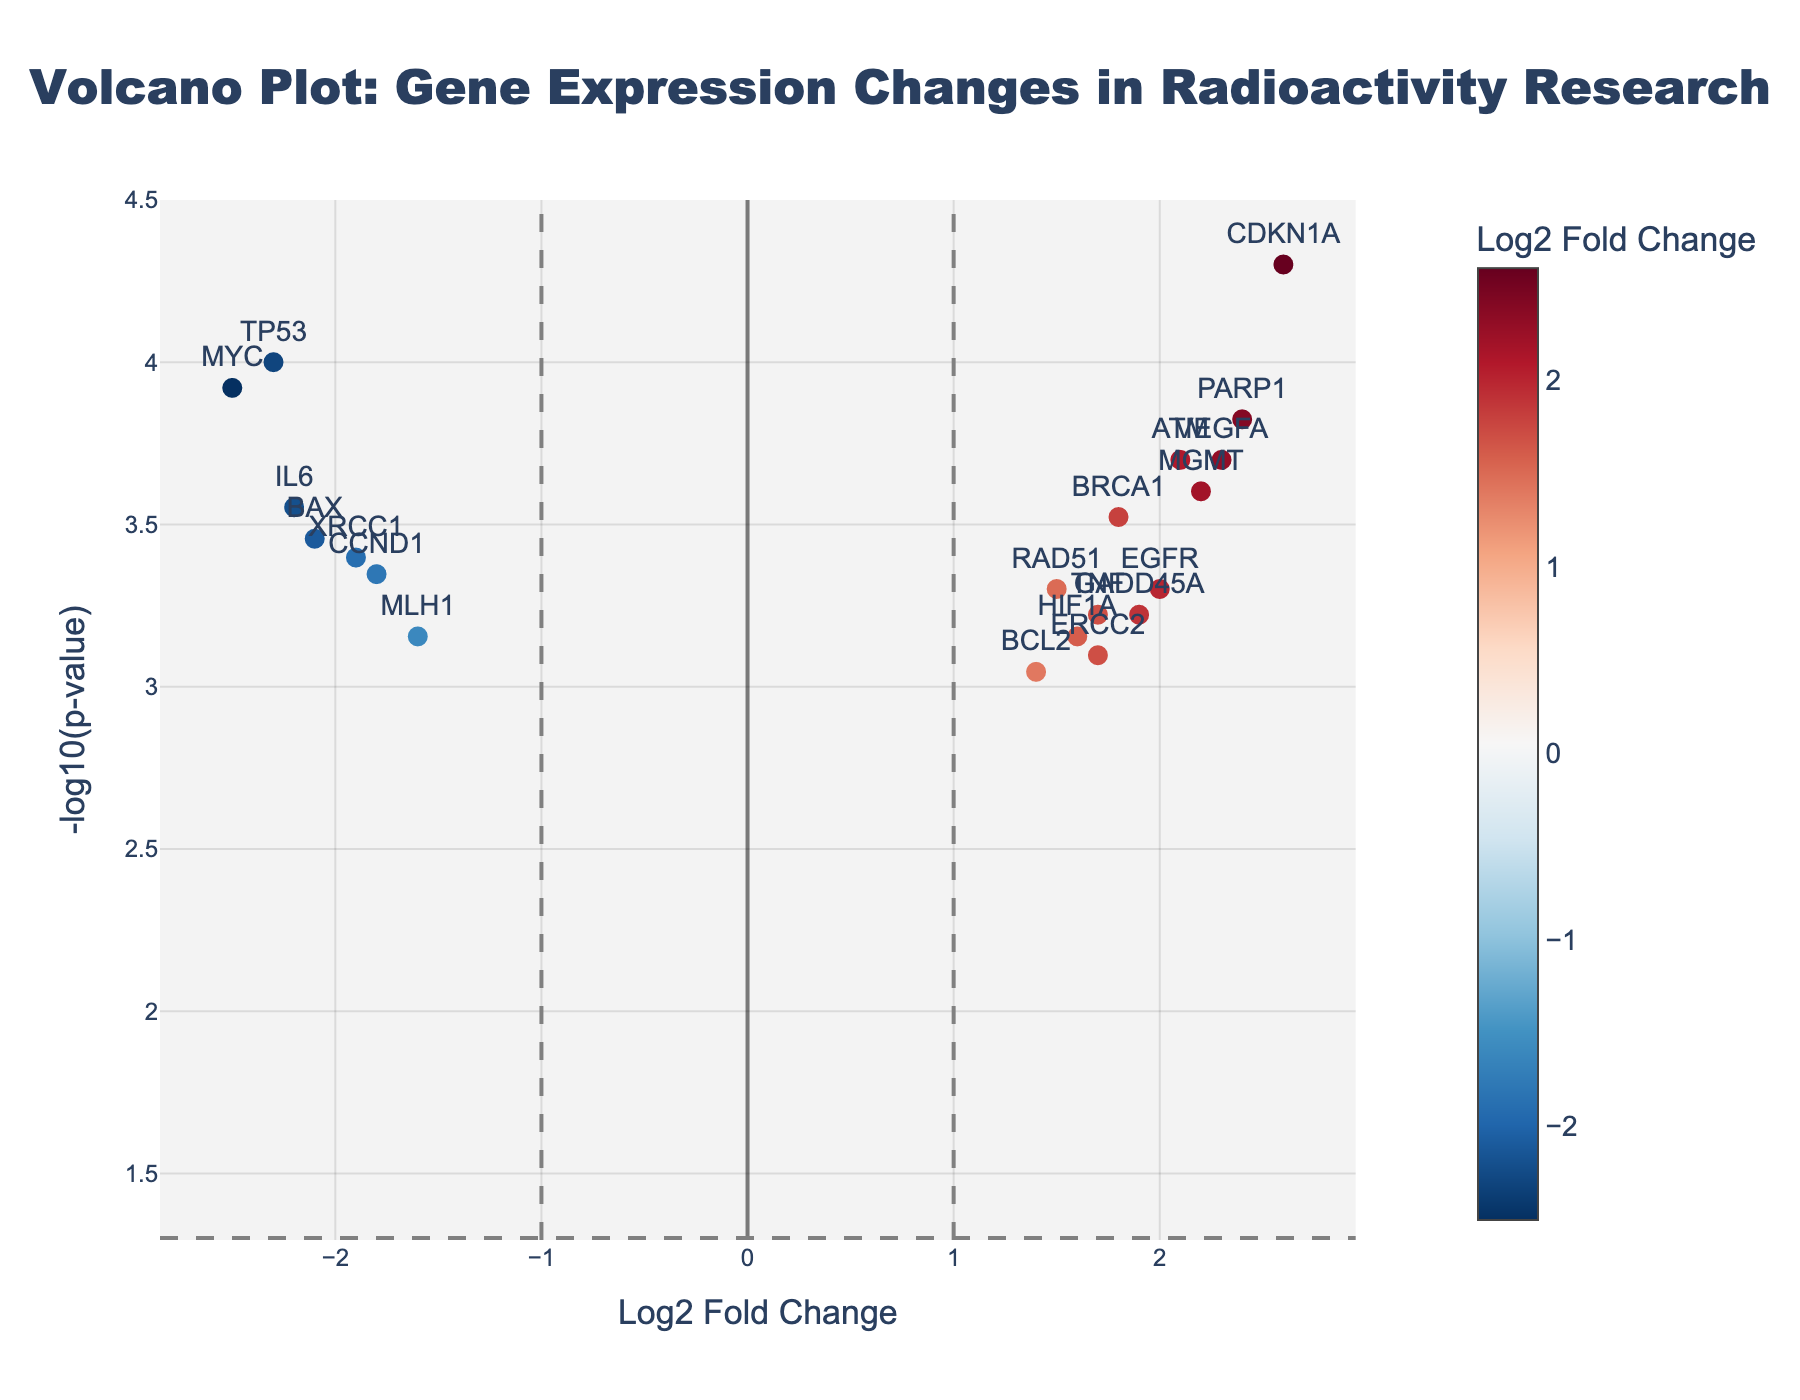What is the title of the figure? The title is usually located at the top of the figure. In this case, it reads "Volcano Plot: Gene Expression Changes in Radioactivity Research".
Answer: "Volcano Plot: Gene Expression Changes in Radioactivity Research" What does the x-axis represent in the plot? The x-axis is labeled "Log2 Fold Change", which indicates the log base 2 of the fold change in gene expression.
Answer: Log2 Fold Change How many genes have a negative Log2 Fold Change? To find this, count the data points on the left side of the zero vertical line on the x-axis.
Answer: 6 Which gene has the highest -log10(p-value)? Find the data point at the highest position on the y-axis, which represents the largest -log10(p-value). The label next to this point is the gene of interest.
Answer: CDKN1A What visual cue indicates the significance of gene expression changes? The plot uses a horizontal line to mark the threshold for significant p-value, which is at y = -log10(0.05). Data points above this line indicate significant changes.
Answer: A horizontal dashed line Name one gene that is upregulated and has a significant p-value. Upregulated genes have a positive Log2 Fold Change. Among these, those above the horizontal significance threshold are considered. For example, PARP1 is above the threshold.
Answer: PARP1 Which gene has the lowest Log2 Fold Change? The data point farthest to the left of the plot has the lowest Log2 Fold Change. Identify the gene label next to that point.
Answer: MYC How does TP53 compare to BAX in terms of gene expression changes? Compare their positions on the x-axis. TP53 is to the left of BAX, indicating a more negative Log2 Fold Change. Both have negative changes.
Answer: TP53 has a more negative change than BAX What pattern can be observed regarding the expression changes and significance among the highlighted genes? Observe the distribution of data points. Upregulated genes (right side) mostly have significant p-values, and downregulated genes (left side) also have several significant p-values.
Answer: Significant changes are widespread in both upregulated and downregulated genes 